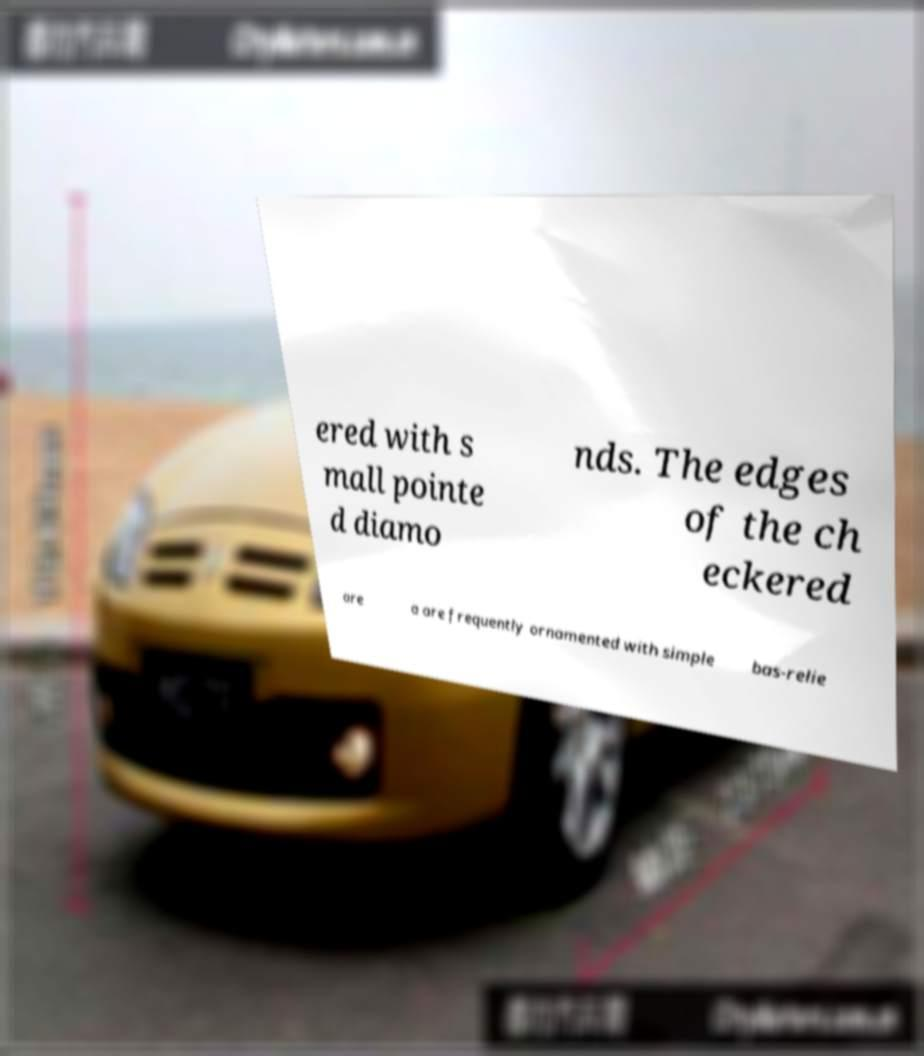Could you extract and type out the text from this image? ered with s mall pointe d diamo nds. The edges of the ch eckered are a are frequently ornamented with simple bas-relie 